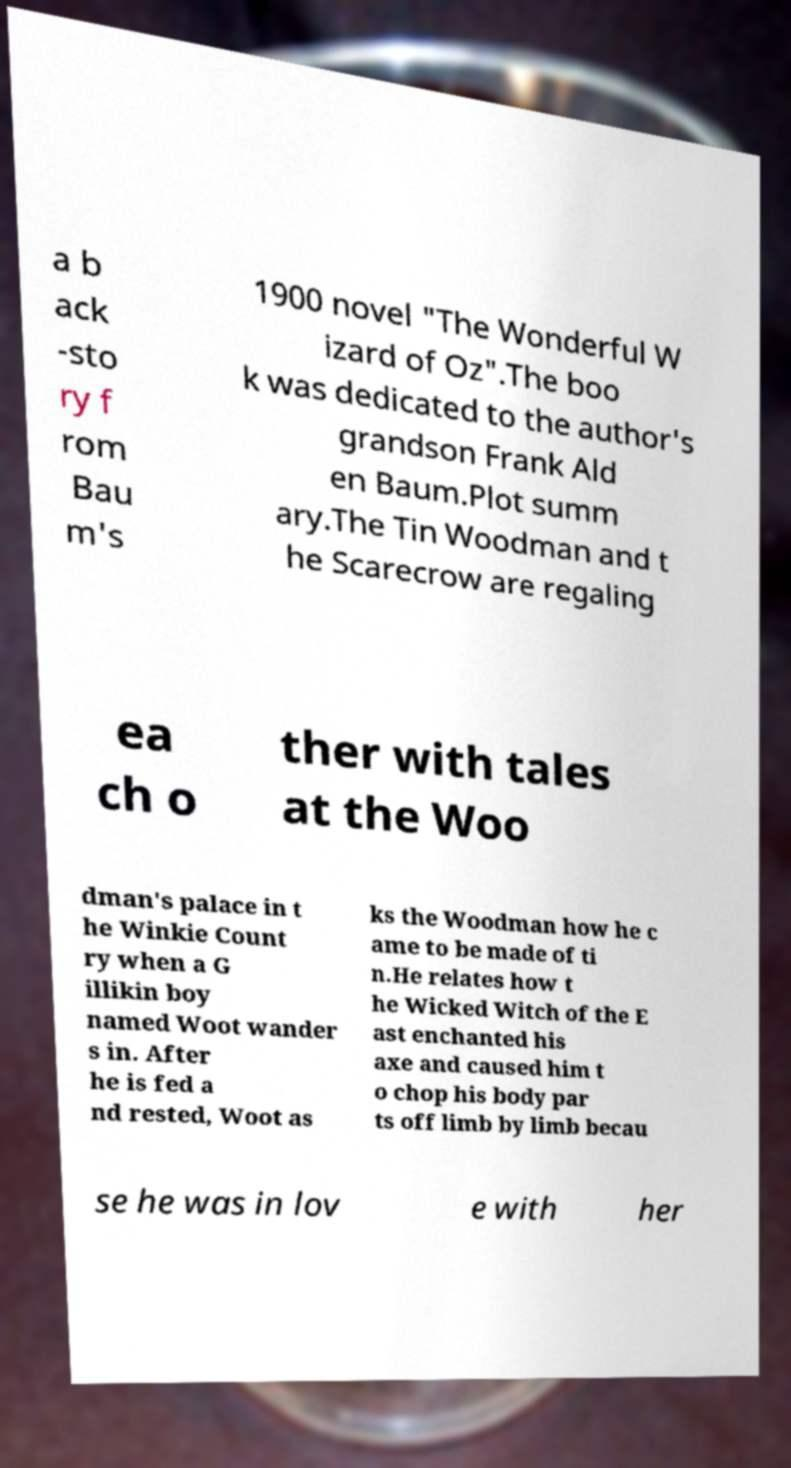Please read and relay the text visible in this image. What does it say? a b ack -sto ry f rom Bau m's 1900 novel "The Wonderful W izard of Oz".The boo k was dedicated to the author's grandson Frank Ald en Baum.Plot summ ary.The Tin Woodman and t he Scarecrow are regaling ea ch o ther with tales at the Woo dman's palace in t he Winkie Count ry when a G illikin boy named Woot wander s in. After he is fed a nd rested, Woot as ks the Woodman how he c ame to be made of ti n.He relates how t he Wicked Witch of the E ast enchanted his axe and caused him t o chop his body par ts off limb by limb becau se he was in lov e with her 